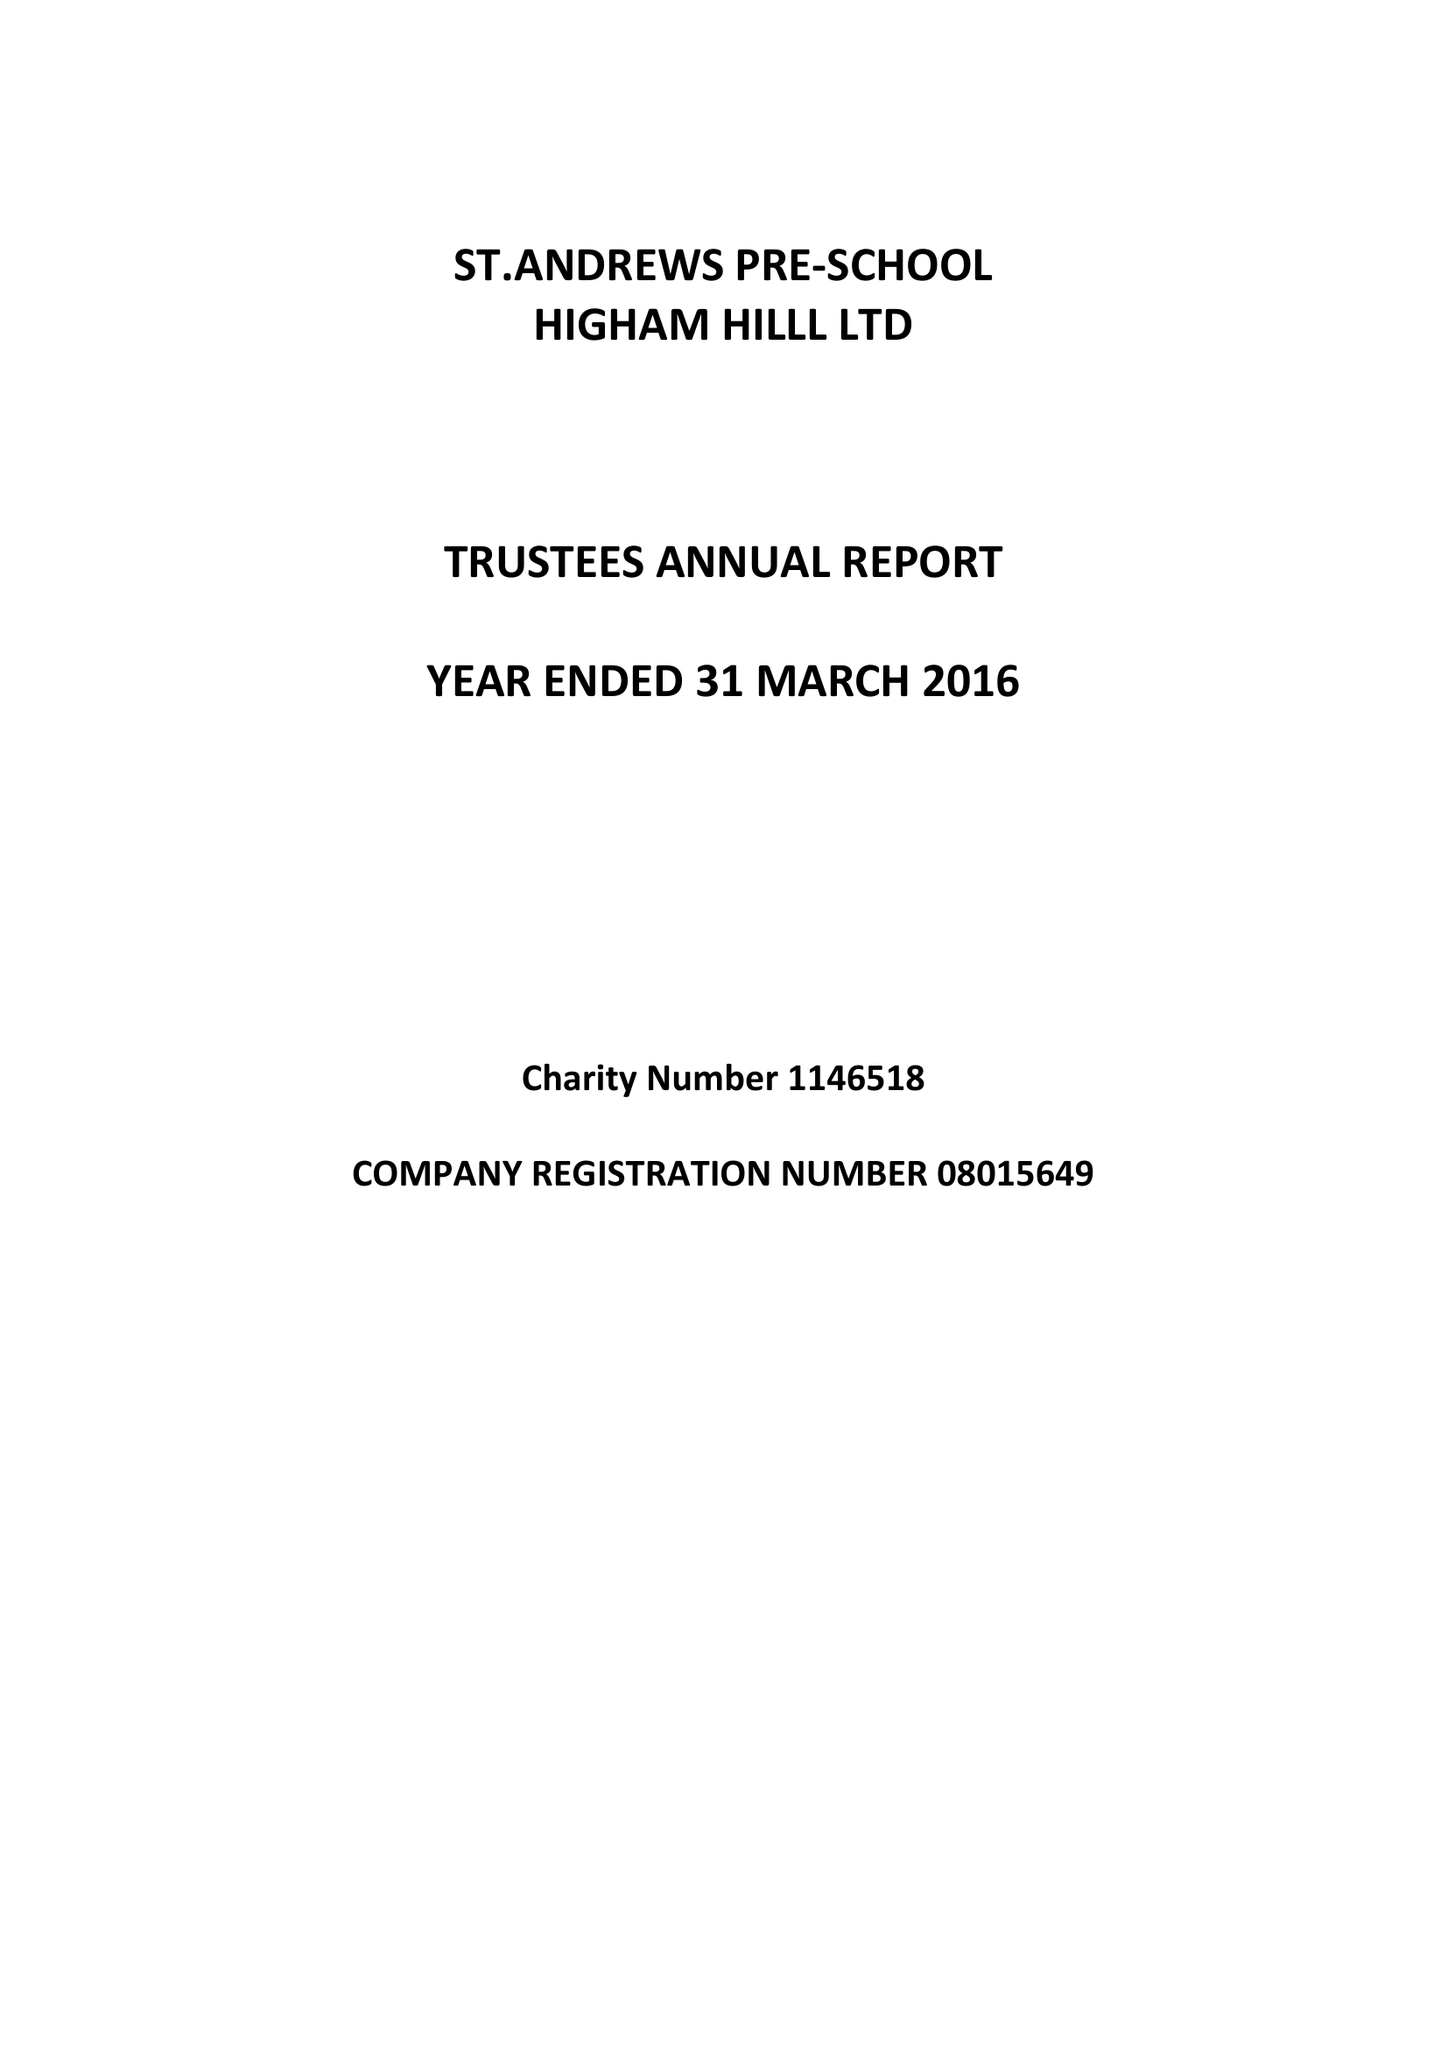What is the value for the address__street_line?
Answer the question using a single word or phrase. CHURCH ROAD 